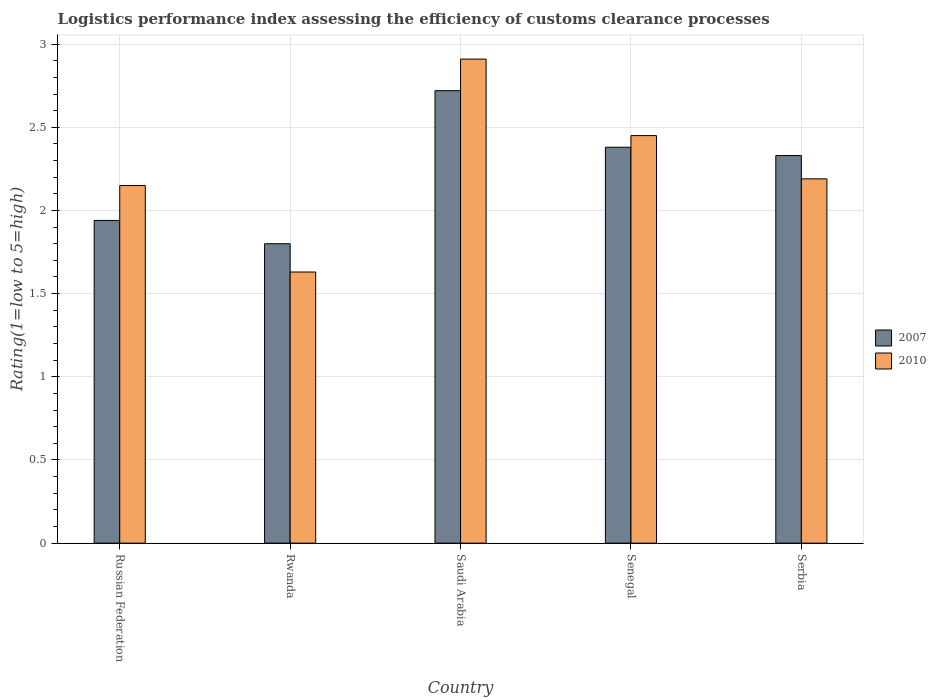How many groups of bars are there?
Offer a terse response. 5. Are the number of bars per tick equal to the number of legend labels?
Your response must be concise. Yes. Are the number of bars on each tick of the X-axis equal?
Ensure brevity in your answer.  Yes. How many bars are there on the 3rd tick from the left?
Make the answer very short. 2. How many bars are there on the 5th tick from the right?
Your answer should be compact. 2. What is the label of the 4th group of bars from the left?
Ensure brevity in your answer.  Senegal. What is the Logistic performance index in 2007 in Rwanda?
Offer a very short reply. 1.8. Across all countries, what is the maximum Logistic performance index in 2007?
Your answer should be very brief. 2.72. In which country was the Logistic performance index in 2007 maximum?
Offer a terse response. Saudi Arabia. In which country was the Logistic performance index in 2010 minimum?
Offer a very short reply. Rwanda. What is the total Logistic performance index in 2007 in the graph?
Provide a short and direct response. 11.17. What is the difference between the Logistic performance index in 2010 in Saudi Arabia and that in Senegal?
Provide a succinct answer. 0.46. What is the difference between the Logistic performance index in 2010 in Saudi Arabia and the Logistic performance index in 2007 in Serbia?
Make the answer very short. 0.58. What is the average Logistic performance index in 2010 per country?
Give a very brief answer. 2.27. What is the difference between the Logistic performance index of/in 2010 and Logistic performance index of/in 2007 in Senegal?
Your response must be concise. 0.07. What is the ratio of the Logistic performance index in 2007 in Rwanda to that in Senegal?
Provide a succinct answer. 0.76. What is the difference between the highest and the second highest Logistic performance index in 2007?
Give a very brief answer. 0.34. What is the difference between the highest and the lowest Logistic performance index in 2010?
Your answer should be very brief. 1.28. Is the sum of the Logistic performance index in 2010 in Russian Federation and Rwanda greater than the maximum Logistic performance index in 2007 across all countries?
Offer a terse response. Yes. What does the 2nd bar from the left in Russian Federation represents?
Your answer should be compact. 2010. How many bars are there?
Give a very brief answer. 10. How many countries are there in the graph?
Give a very brief answer. 5. Are the values on the major ticks of Y-axis written in scientific E-notation?
Provide a succinct answer. No. Where does the legend appear in the graph?
Give a very brief answer. Center right. What is the title of the graph?
Give a very brief answer. Logistics performance index assessing the efficiency of customs clearance processes. What is the label or title of the Y-axis?
Ensure brevity in your answer.  Rating(1=low to 5=high). What is the Rating(1=low to 5=high) in 2007 in Russian Federation?
Give a very brief answer. 1.94. What is the Rating(1=low to 5=high) in 2010 in Russian Federation?
Provide a succinct answer. 2.15. What is the Rating(1=low to 5=high) of 2010 in Rwanda?
Provide a short and direct response. 1.63. What is the Rating(1=low to 5=high) in 2007 in Saudi Arabia?
Provide a succinct answer. 2.72. What is the Rating(1=low to 5=high) in 2010 in Saudi Arabia?
Make the answer very short. 2.91. What is the Rating(1=low to 5=high) in 2007 in Senegal?
Ensure brevity in your answer.  2.38. What is the Rating(1=low to 5=high) in 2010 in Senegal?
Ensure brevity in your answer.  2.45. What is the Rating(1=low to 5=high) of 2007 in Serbia?
Keep it short and to the point. 2.33. What is the Rating(1=low to 5=high) of 2010 in Serbia?
Give a very brief answer. 2.19. Across all countries, what is the maximum Rating(1=low to 5=high) of 2007?
Provide a succinct answer. 2.72. Across all countries, what is the maximum Rating(1=low to 5=high) of 2010?
Your response must be concise. 2.91. Across all countries, what is the minimum Rating(1=low to 5=high) of 2010?
Give a very brief answer. 1.63. What is the total Rating(1=low to 5=high) in 2007 in the graph?
Make the answer very short. 11.17. What is the total Rating(1=low to 5=high) in 2010 in the graph?
Make the answer very short. 11.33. What is the difference between the Rating(1=low to 5=high) in 2007 in Russian Federation and that in Rwanda?
Your answer should be very brief. 0.14. What is the difference between the Rating(1=low to 5=high) in 2010 in Russian Federation and that in Rwanda?
Your answer should be very brief. 0.52. What is the difference between the Rating(1=low to 5=high) in 2007 in Russian Federation and that in Saudi Arabia?
Offer a very short reply. -0.78. What is the difference between the Rating(1=low to 5=high) in 2010 in Russian Federation and that in Saudi Arabia?
Your answer should be very brief. -0.76. What is the difference between the Rating(1=low to 5=high) of 2007 in Russian Federation and that in Senegal?
Make the answer very short. -0.44. What is the difference between the Rating(1=low to 5=high) in 2010 in Russian Federation and that in Senegal?
Ensure brevity in your answer.  -0.3. What is the difference between the Rating(1=low to 5=high) of 2007 in Russian Federation and that in Serbia?
Provide a succinct answer. -0.39. What is the difference between the Rating(1=low to 5=high) of 2010 in Russian Federation and that in Serbia?
Your response must be concise. -0.04. What is the difference between the Rating(1=low to 5=high) in 2007 in Rwanda and that in Saudi Arabia?
Keep it short and to the point. -0.92. What is the difference between the Rating(1=low to 5=high) of 2010 in Rwanda and that in Saudi Arabia?
Offer a terse response. -1.28. What is the difference between the Rating(1=low to 5=high) in 2007 in Rwanda and that in Senegal?
Your answer should be very brief. -0.58. What is the difference between the Rating(1=low to 5=high) of 2010 in Rwanda and that in Senegal?
Offer a terse response. -0.82. What is the difference between the Rating(1=low to 5=high) of 2007 in Rwanda and that in Serbia?
Make the answer very short. -0.53. What is the difference between the Rating(1=low to 5=high) of 2010 in Rwanda and that in Serbia?
Make the answer very short. -0.56. What is the difference between the Rating(1=low to 5=high) of 2007 in Saudi Arabia and that in Senegal?
Ensure brevity in your answer.  0.34. What is the difference between the Rating(1=low to 5=high) of 2010 in Saudi Arabia and that in Senegal?
Make the answer very short. 0.46. What is the difference between the Rating(1=low to 5=high) of 2007 in Saudi Arabia and that in Serbia?
Keep it short and to the point. 0.39. What is the difference between the Rating(1=low to 5=high) of 2010 in Saudi Arabia and that in Serbia?
Make the answer very short. 0.72. What is the difference between the Rating(1=low to 5=high) of 2007 in Senegal and that in Serbia?
Provide a succinct answer. 0.05. What is the difference between the Rating(1=low to 5=high) of 2010 in Senegal and that in Serbia?
Your answer should be compact. 0.26. What is the difference between the Rating(1=low to 5=high) of 2007 in Russian Federation and the Rating(1=low to 5=high) of 2010 in Rwanda?
Keep it short and to the point. 0.31. What is the difference between the Rating(1=low to 5=high) of 2007 in Russian Federation and the Rating(1=low to 5=high) of 2010 in Saudi Arabia?
Provide a short and direct response. -0.97. What is the difference between the Rating(1=low to 5=high) of 2007 in Russian Federation and the Rating(1=low to 5=high) of 2010 in Senegal?
Your answer should be very brief. -0.51. What is the difference between the Rating(1=low to 5=high) of 2007 in Rwanda and the Rating(1=low to 5=high) of 2010 in Saudi Arabia?
Ensure brevity in your answer.  -1.11. What is the difference between the Rating(1=low to 5=high) of 2007 in Rwanda and the Rating(1=low to 5=high) of 2010 in Senegal?
Your answer should be very brief. -0.65. What is the difference between the Rating(1=low to 5=high) in 2007 in Rwanda and the Rating(1=low to 5=high) in 2010 in Serbia?
Give a very brief answer. -0.39. What is the difference between the Rating(1=low to 5=high) of 2007 in Saudi Arabia and the Rating(1=low to 5=high) of 2010 in Senegal?
Give a very brief answer. 0.27. What is the difference between the Rating(1=low to 5=high) in 2007 in Saudi Arabia and the Rating(1=low to 5=high) in 2010 in Serbia?
Offer a terse response. 0.53. What is the difference between the Rating(1=low to 5=high) of 2007 in Senegal and the Rating(1=low to 5=high) of 2010 in Serbia?
Keep it short and to the point. 0.19. What is the average Rating(1=low to 5=high) in 2007 per country?
Your response must be concise. 2.23. What is the average Rating(1=low to 5=high) in 2010 per country?
Offer a terse response. 2.27. What is the difference between the Rating(1=low to 5=high) in 2007 and Rating(1=low to 5=high) in 2010 in Russian Federation?
Make the answer very short. -0.21. What is the difference between the Rating(1=low to 5=high) in 2007 and Rating(1=low to 5=high) in 2010 in Rwanda?
Keep it short and to the point. 0.17. What is the difference between the Rating(1=low to 5=high) in 2007 and Rating(1=low to 5=high) in 2010 in Saudi Arabia?
Give a very brief answer. -0.19. What is the difference between the Rating(1=low to 5=high) of 2007 and Rating(1=low to 5=high) of 2010 in Senegal?
Ensure brevity in your answer.  -0.07. What is the difference between the Rating(1=low to 5=high) in 2007 and Rating(1=low to 5=high) in 2010 in Serbia?
Ensure brevity in your answer.  0.14. What is the ratio of the Rating(1=low to 5=high) in 2007 in Russian Federation to that in Rwanda?
Offer a terse response. 1.08. What is the ratio of the Rating(1=low to 5=high) of 2010 in Russian Federation to that in Rwanda?
Your answer should be compact. 1.32. What is the ratio of the Rating(1=low to 5=high) of 2007 in Russian Federation to that in Saudi Arabia?
Offer a very short reply. 0.71. What is the ratio of the Rating(1=low to 5=high) in 2010 in Russian Federation to that in Saudi Arabia?
Offer a very short reply. 0.74. What is the ratio of the Rating(1=low to 5=high) in 2007 in Russian Federation to that in Senegal?
Offer a terse response. 0.82. What is the ratio of the Rating(1=low to 5=high) in 2010 in Russian Federation to that in Senegal?
Your answer should be compact. 0.88. What is the ratio of the Rating(1=low to 5=high) in 2007 in Russian Federation to that in Serbia?
Your answer should be very brief. 0.83. What is the ratio of the Rating(1=low to 5=high) of 2010 in Russian Federation to that in Serbia?
Your response must be concise. 0.98. What is the ratio of the Rating(1=low to 5=high) of 2007 in Rwanda to that in Saudi Arabia?
Provide a succinct answer. 0.66. What is the ratio of the Rating(1=low to 5=high) of 2010 in Rwanda to that in Saudi Arabia?
Your response must be concise. 0.56. What is the ratio of the Rating(1=low to 5=high) in 2007 in Rwanda to that in Senegal?
Give a very brief answer. 0.76. What is the ratio of the Rating(1=low to 5=high) in 2010 in Rwanda to that in Senegal?
Provide a short and direct response. 0.67. What is the ratio of the Rating(1=low to 5=high) in 2007 in Rwanda to that in Serbia?
Provide a short and direct response. 0.77. What is the ratio of the Rating(1=low to 5=high) in 2010 in Rwanda to that in Serbia?
Provide a succinct answer. 0.74. What is the ratio of the Rating(1=low to 5=high) in 2007 in Saudi Arabia to that in Senegal?
Your answer should be very brief. 1.14. What is the ratio of the Rating(1=low to 5=high) in 2010 in Saudi Arabia to that in Senegal?
Offer a terse response. 1.19. What is the ratio of the Rating(1=low to 5=high) of 2007 in Saudi Arabia to that in Serbia?
Ensure brevity in your answer.  1.17. What is the ratio of the Rating(1=low to 5=high) of 2010 in Saudi Arabia to that in Serbia?
Your answer should be very brief. 1.33. What is the ratio of the Rating(1=low to 5=high) in 2007 in Senegal to that in Serbia?
Make the answer very short. 1.02. What is the ratio of the Rating(1=low to 5=high) in 2010 in Senegal to that in Serbia?
Your answer should be very brief. 1.12. What is the difference between the highest and the second highest Rating(1=low to 5=high) in 2007?
Keep it short and to the point. 0.34. What is the difference between the highest and the second highest Rating(1=low to 5=high) in 2010?
Provide a succinct answer. 0.46. What is the difference between the highest and the lowest Rating(1=low to 5=high) in 2010?
Make the answer very short. 1.28. 